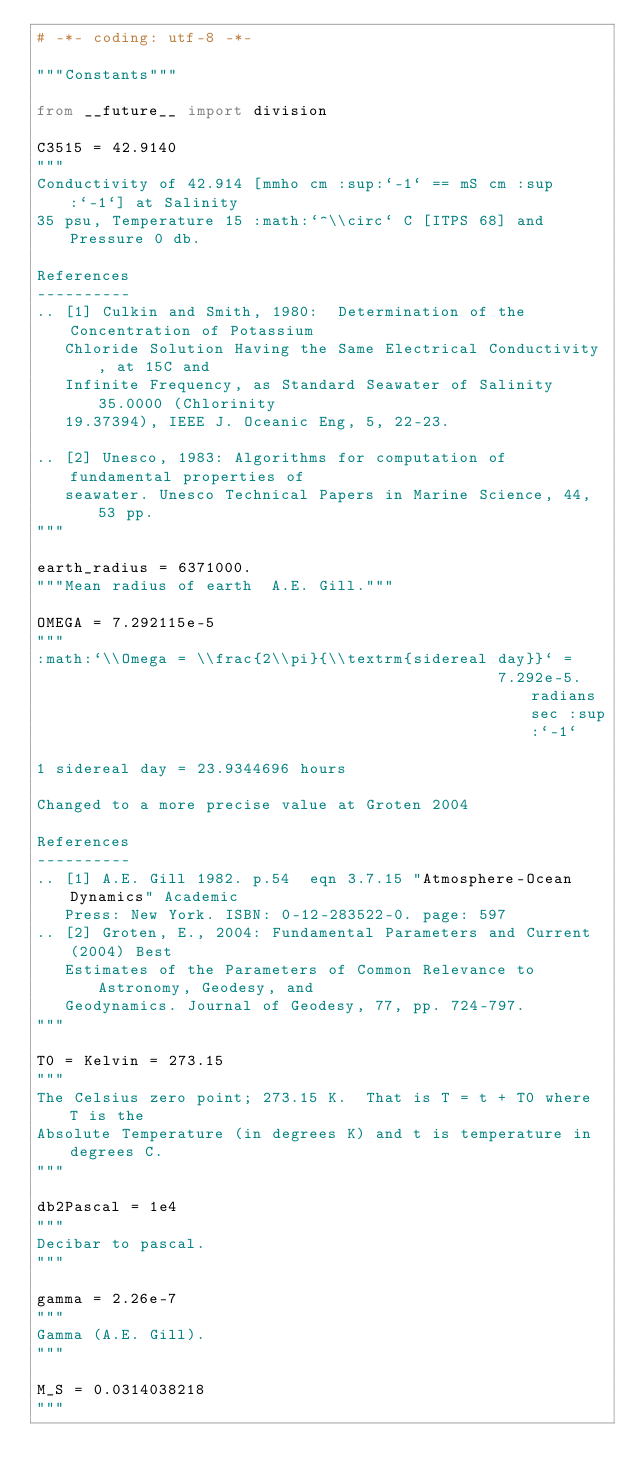<code> <loc_0><loc_0><loc_500><loc_500><_Python_># -*- coding: utf-8 -*-

"""Constants"""

from __future__ import division

C3515 = 42.9140
"""
Conductivity of 42.914 [mmho cm :sup:`-1` == mS cm :sup:`-1`] at Salinity
35 psu, Temperature 15 :math:`^\\circ` C [ITPS 68] and Pressure 0 db.

References
----------
.. [1] Culkin and Smith, 1980:  Determination of the Concentration of Potassium
   Chloride Solution Having the Same Electrical Conductivity, at 15C and
   Infinite Frequency, as Standard Seawater of Salinity 35.0000 (Chlorinity
   19.37394), IEEE J. Oceanic Eng, 5, 22-23.

.. [2] Unesco, 1983: Algorithms for computation of fundamental properties of
   seawater. Unesco Technical Papers in Marine Science, 44, 53 pp.
"""

earth_radius = 6371000.
"""Mean radius of earth  A.E. Gill."""

OMEGA = 7.292115e-5
"""
:math:`\\Omega = \\frac{2\\pi}{\\textrm{sidereal day}}` =
                                                 7.292e-5.radians sec :sup:`-1`

1 sidereal day = 23.9344696 hours

Changed to a more precise value at Groten 2004

References
----------
.. [1] A.E. Gill 1982. p.54  eqn 3.7.15 "Atmosphere-Ocean Dynamics" Academic
   Press: New York. ISBN: 0-12-283522-0. page: 597
.. [2] Groten, E., 2004: Fundamental Parameters and Current (2004) Best
   Estimates of the Parameters of Common Relevance to Astronomy, Geodesy, and
   Geodynamics. Journal of Geodesy, 77, pp. 724-797.
"""

T0 = Kelvin = 273.15
"""
The Celsius zero point; 273.15 K.  That is T = t + T0 where T is the
Absolute Temperature (in degrees K) and t is temperature in degrees C.
"""

db2Pascal = 1e4
"""
Decibar to pascal.
"""

gamma = 2.26e-7
"""
Gamma (A.E. Gill).
"""

M_S = 0.0314038218
"""</code> 